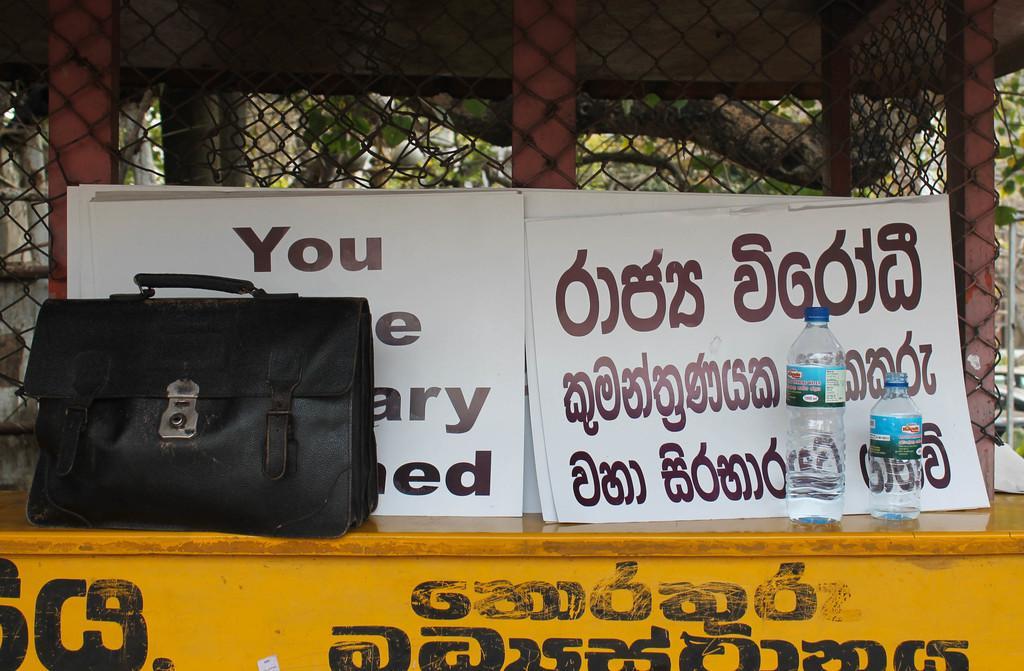Could you give a brief overview of what you see in this image? As we can see in the image, there is a fence, posters, bottles and a black color bag. 